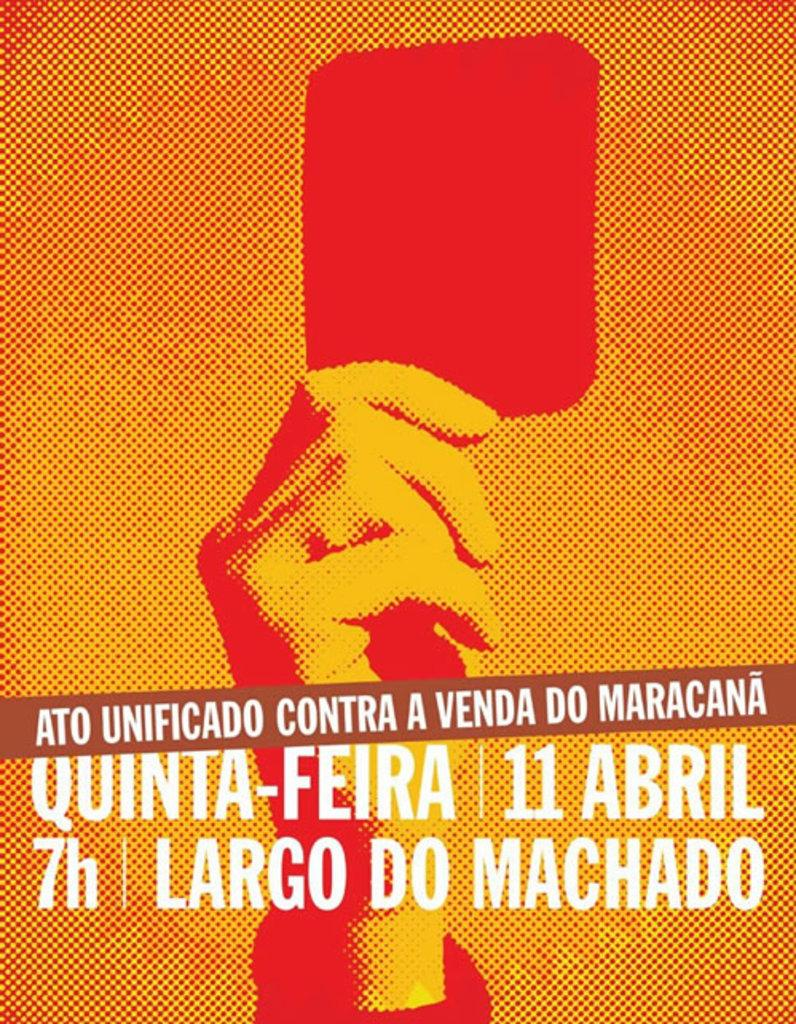<image>
Create a compact narrative representing the image presented. Poster that says "Largo Do Machado" for 7 hours. 